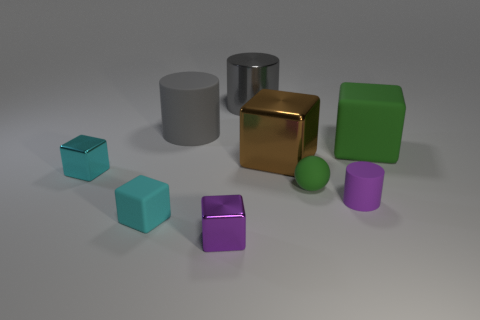What might be the purpose of creating such an image? This image could have multiple purposes. It might be a rendering to showcase 3D modeling skills, an example in a lesson on geometry and light in computer graphics, or a visual aid for demonstrations in material properties and how they interact with light. 